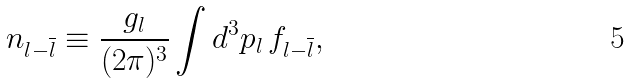<formula> <loc_0><loc_0><loc_500><loc_500>n _ { l - \overline { l } } \equiv \frac { g _ { l } } { ( 2 \pi ) ^ { 3 } } \int d ^ { 3 } p _ { l } \, f _ { l - \overline { l } } ,</formula> 